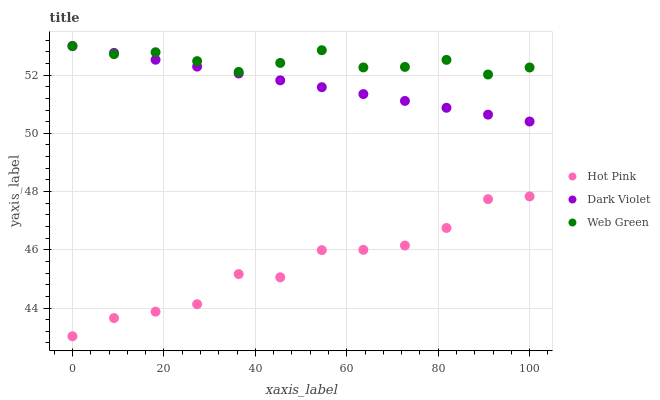Does Hot Pink have the minimum area under the curve?
Answer yes or no. Yes. Does Web Green have the maximum area under the curve?
Answer yes or no. Yes. Does Dark Violet have the minimum area under the curve?
Answer yes or no. No. Does Dark Violet have the maximum area under the curve?
Answer yes or no. No. Is Dark Violet the smoothest?
Answer yes or no. Yes. Is Hot Pink the roughest?
Answer yes or no. Yes. Is Web Green the smoothest?
Answer yes or no. No. Is Web Green the roughest?
Answer yes or no. No. Does Hot Pink have the lowest value?
Answer yes or no. Yes. Does Dark Violet have the lowest value?
Answer yes or no. No. Does Dark Violet have the highest value?
Answer yes or no. Yes. Is Hot Pink less than Web Green?
Answer yes or no. Yes. Is Web Green greater than Hot Pink?
Answer yes or no. Yes. Does Web Green intersect Dark Violet?
Answer yes or no. Yes. Is Web Green less than Dark Violet?
Answer yes or no. No. Is Web Green greater than Dark Violet?
Answer yes or no. No. Does Hot Pink intersect Web Green?
Answer yes or no. No. 